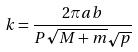<formula> <loc_0><loc_0><loc_500><loc_500>k = \frac { 2 \pi a b } { P \sqrt { M + m } \sqrt { p } }</formula> 